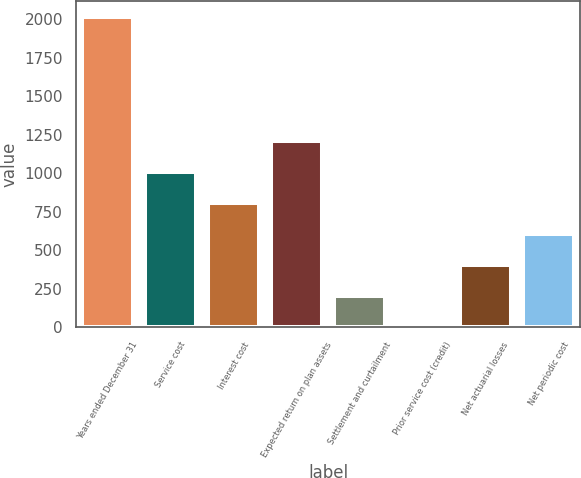<chart> <loc_0><loc_0><loc_500><loc_500><bar_chart><fcel>Years ended December 31<fcel>Service cost<fcel>Interest cost<fcel>Expected return on plan assets<fcel>Settlement and curtailment<fcel>Prior service cost (credit)<fcel>Net actuarial losses<fcel>Net periodic cost<nl><fcel>2015<fcel>1007.55<fcel>806.06<fcel>1209.04<fcel>201.59<fcel>0.1<fcel>403.08<fcel>604.57<nl></chart> 